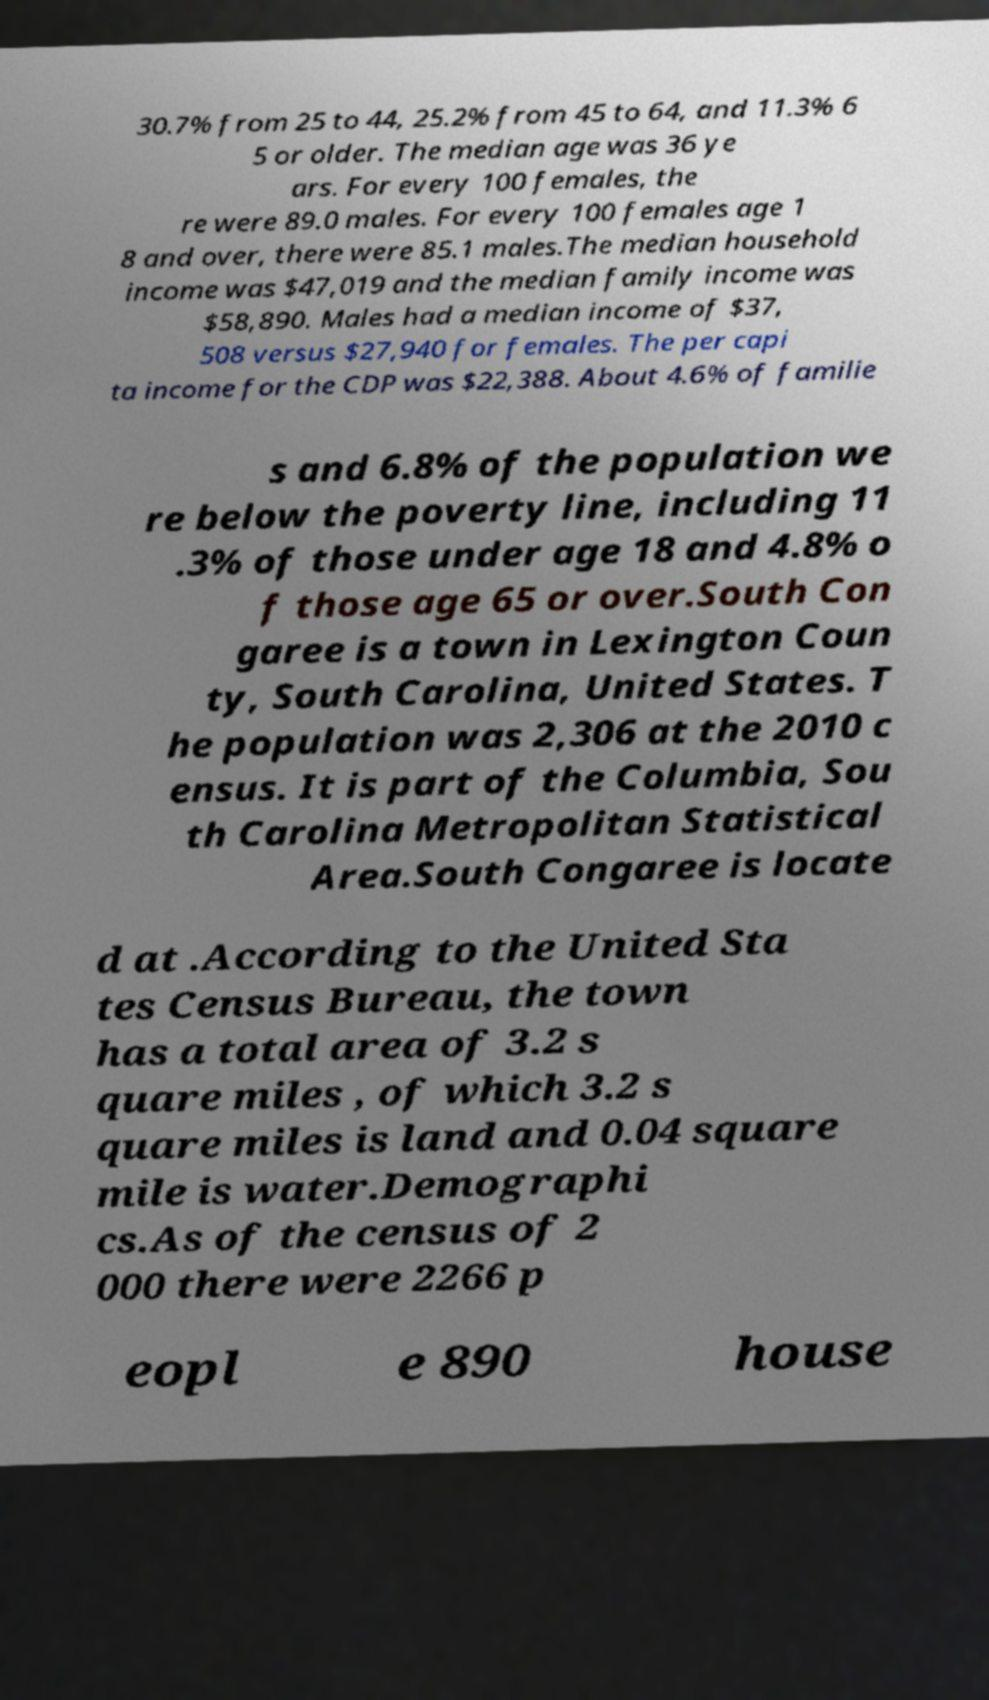Could you assist in decoding the text presented in this image and type it out clearly? 30.7% from 25 to 44, 25.2% from 45 to 64, and 11.3% 6 5 or older. The median age was 36 ye ars. For every 100 females, the re were 89.0 males. For every 100 females age 1 8 and over, there were 85.1 males.The median household income was $47,019 and the median family income was $58,890. Males had a median income of $37, 508 versus $27,940 for females. The per capi ta income for the CDP was $22,388. About 4.6% of familie s and 6.8% of the population we re below the poverty line, including 11 .3% of those under age 18 and 4.8% o f those age 65 or over.South Con garee is a town in Lexington Coun ty, South Carolina, United States. T he population was 2,306 at the 2010 c ensus. It is part of the Columbia, Sou th Carolina Metropolitan Statistical Area.South Congaree is locate d at .According to the United Sta tes Census Bureau, the town has a total area of 3.2 s quare miles , of which 3.2 s quare miles is land and 0.04 square mile is water.Demographi cs.As of the census of 2 000 there were 2266 p eopl e 890 house 